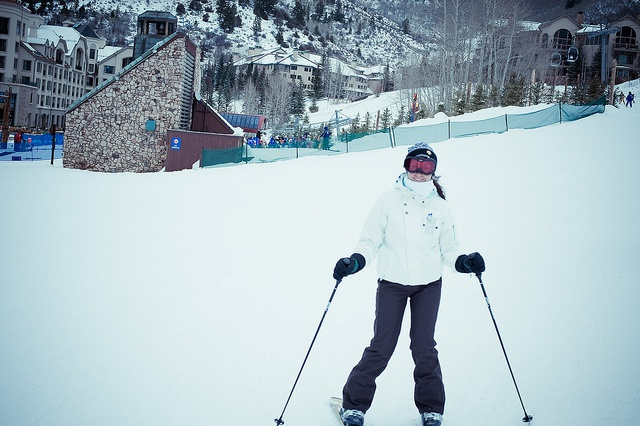Describe the objects in this image and their specific colors. I can see people in black, lightgray, navy, and lightblue tones, skis in black, lightgray, lightblue, darkgray, and gray tones, people in black, navy, gray, and darkblue tones, people in black, gray, darkgray, and lavender tones, and people in black, gray, and darkgray tones in this image. 